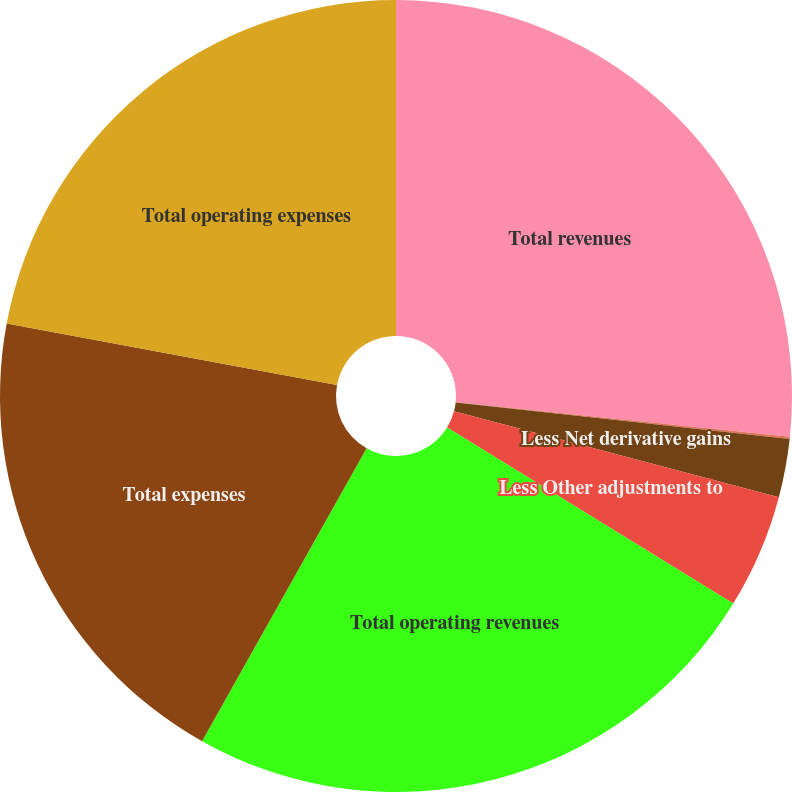<chart> <loc_0><loc_0><loc_500><loc_500><pie_chart><fcel>Total revenues<fcel>Less Net investment gains<fcel>Less Net derivative gains<fcel>Less Other adjustments to<fcel>Total operating revenues<fcel>Total expenses<fcel>Total operating expenses<nl><fcel>26.64%<fcel>0.09%<fcel>2.38%<fcel>4.67%<fcel>24.36%<fcel>19.78%<fcel>22.07%<nl></chart> 